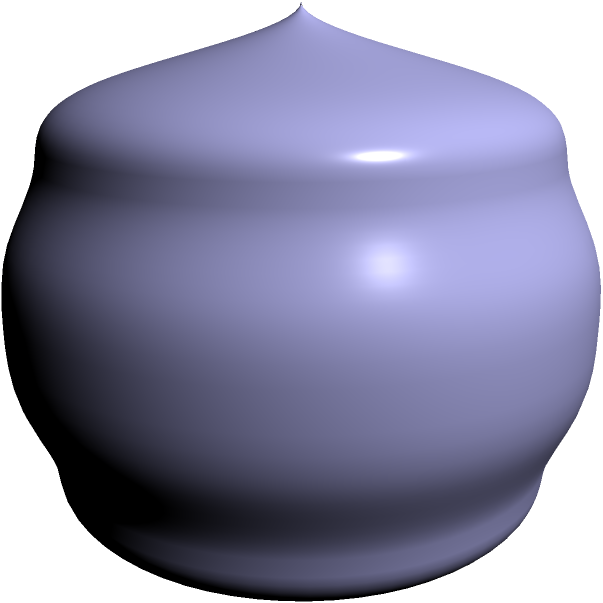As a game developer working on audio effects, you need to optimize the volume of a 3D sound cone in your game environment. The cone has a height $h$ and a circular base with radius $r$. The relationship between $h$ and $r$ is given by $r^2 = h(3-h)$, where $0 \leq h \leq 3$. Find the maximum volume of the sound cone using multivariable calculus. Let's approach this step-by-step:

1) The volume of a cone is given by $V = \frac{1}{3}\pi r^2 h$.

2) We're given that $r^2 = h(3-h)$. Substituting this into the volume formula:
   $V = \frac{1}{3}\pi h(3-h)h = \frac{1}{3}\pi h^2(3-h)$

3) Now we have a function of one variable $h$. To find the maximum volume, we need to find where $\frac{dV}{dh} = 0$.

4) Let's differentiate $V$ with respect to $h$:
   $\frac{dV}{dh} = \frac{1}{3}\pi(2h(3-h) + h^2(-1)) = \frac{1}{3}\pi h(6-3h)$

5) Setting this equal to zero:
   $\frac{1}{3}\pi h(6-3h) = 0$

6) Solving this equation:
   $h = 0$ or $6-3h = 0$
   $h = 0$ or $h = 2$

7) $h = 0$ would give us a cone with no volume, so the maximum must occur at $h = 2$.

8) To confirm this is a maximum, we could check the second derivative is negative at $h = 2$, or note that the volume is zero at $h = 0$ and $h = 3$, so $h = 2$ must give a maximum.

9) To find the maximum volume, we substitute $h = 2$ back into our volume equation:
   $V_{max} = \frac{1}{3}\pi (2^2)(3-2) = \frac{4}{3}\pi$

Therefore, the maximum volume of the sound cone is $\frac{4}{3}\pi$ cubic units.
Answer: $\frac{4}{3}\pi$ cubic units 